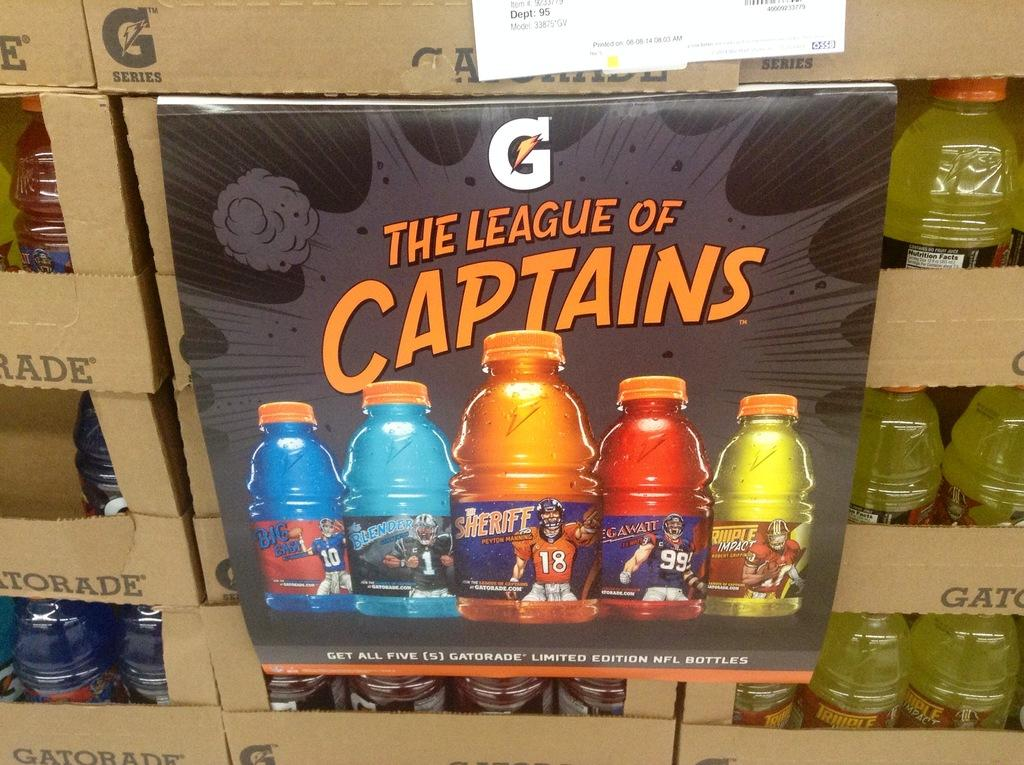<image>
Describe the image concisely. Bottles of Gatorade sit on top of each other with a sign saying League of Captains on it. 